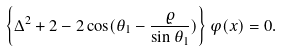<formula> <loc_0><loc_0><loc_500><loc_500>\left \{ \Delta ^ { 2 } + 2 - 2 \cos ( \theta _ { 1 } - \frac { \varrho } { \sin \theta _ { 1 } } ) \right \} \varphi ( x ) = 0 .</formula> 